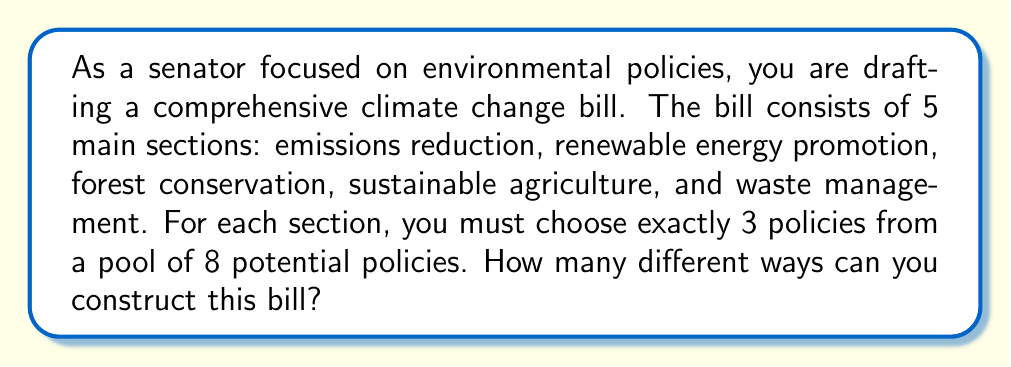Solve this math problem. Let's approach this problem step-by-step:

1) For each section, we need to choose 3 policies out of 8 available options. This is a combination problem.

2) The number of ways to choose 3 items from 8 is denoted as $\binom{8}{3}$ or $C(8,3)$.

3) We can calculate this using the combination formula:

   $$\binom{8}{3} = \frac{8!}{3!(8-3)!} = \frac{8!}{3!5!}$$

4) Expanding this:
   $$\frac{8 \cdot 7 \cdot 6 \cdot 5!}{(3 \cdot 2 \cdot 1) \cdot 5!} = \frac{336}{6} = 56$$

5) So, for each section, there are 56 ways to choose the policies.

6) Since we have 5 independent sections, and for each section we make a choice from 56 possibilities, we multiply these together:

   $$56 \cdot 56 \cdot 56 \cdot 56 \cdot 56 = 56^5$$

7) Calculate $56^5$:
   $$56^5 = 550,731,776$$

Therefore, there are 550,731,776 different ways to construct this bill.
Answer: $56^5 = 550,731,776$ 